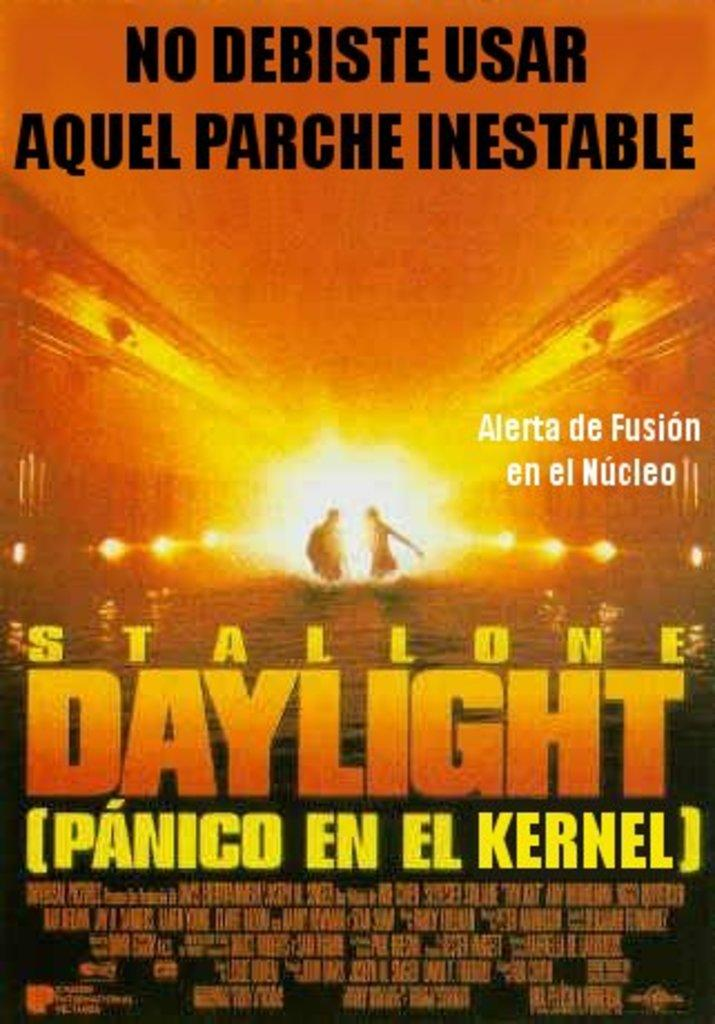<image>
Write a terse but informative summary of the picture. Poster that says "No Debiste Usar Aquel Parche Inestable" on the top. 